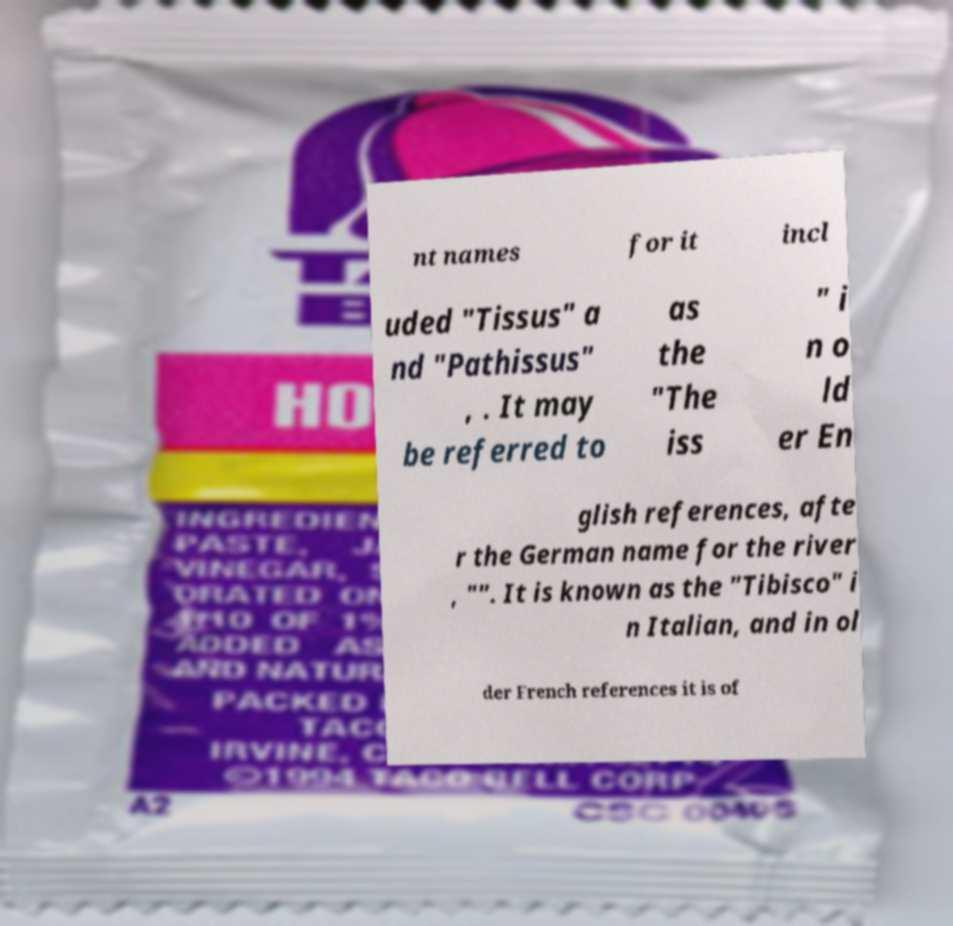Could you assist in decoding the text presented in this image and type it out clearly? nt names for it incl uded "Tissus" a nd "Pathissus" , . It may be referred to as the "The iss " i n o ld er En glish references, afte r the German name for the river , "". It is known as the "Tibisco" i n Italian, and in ol der French references it is of 